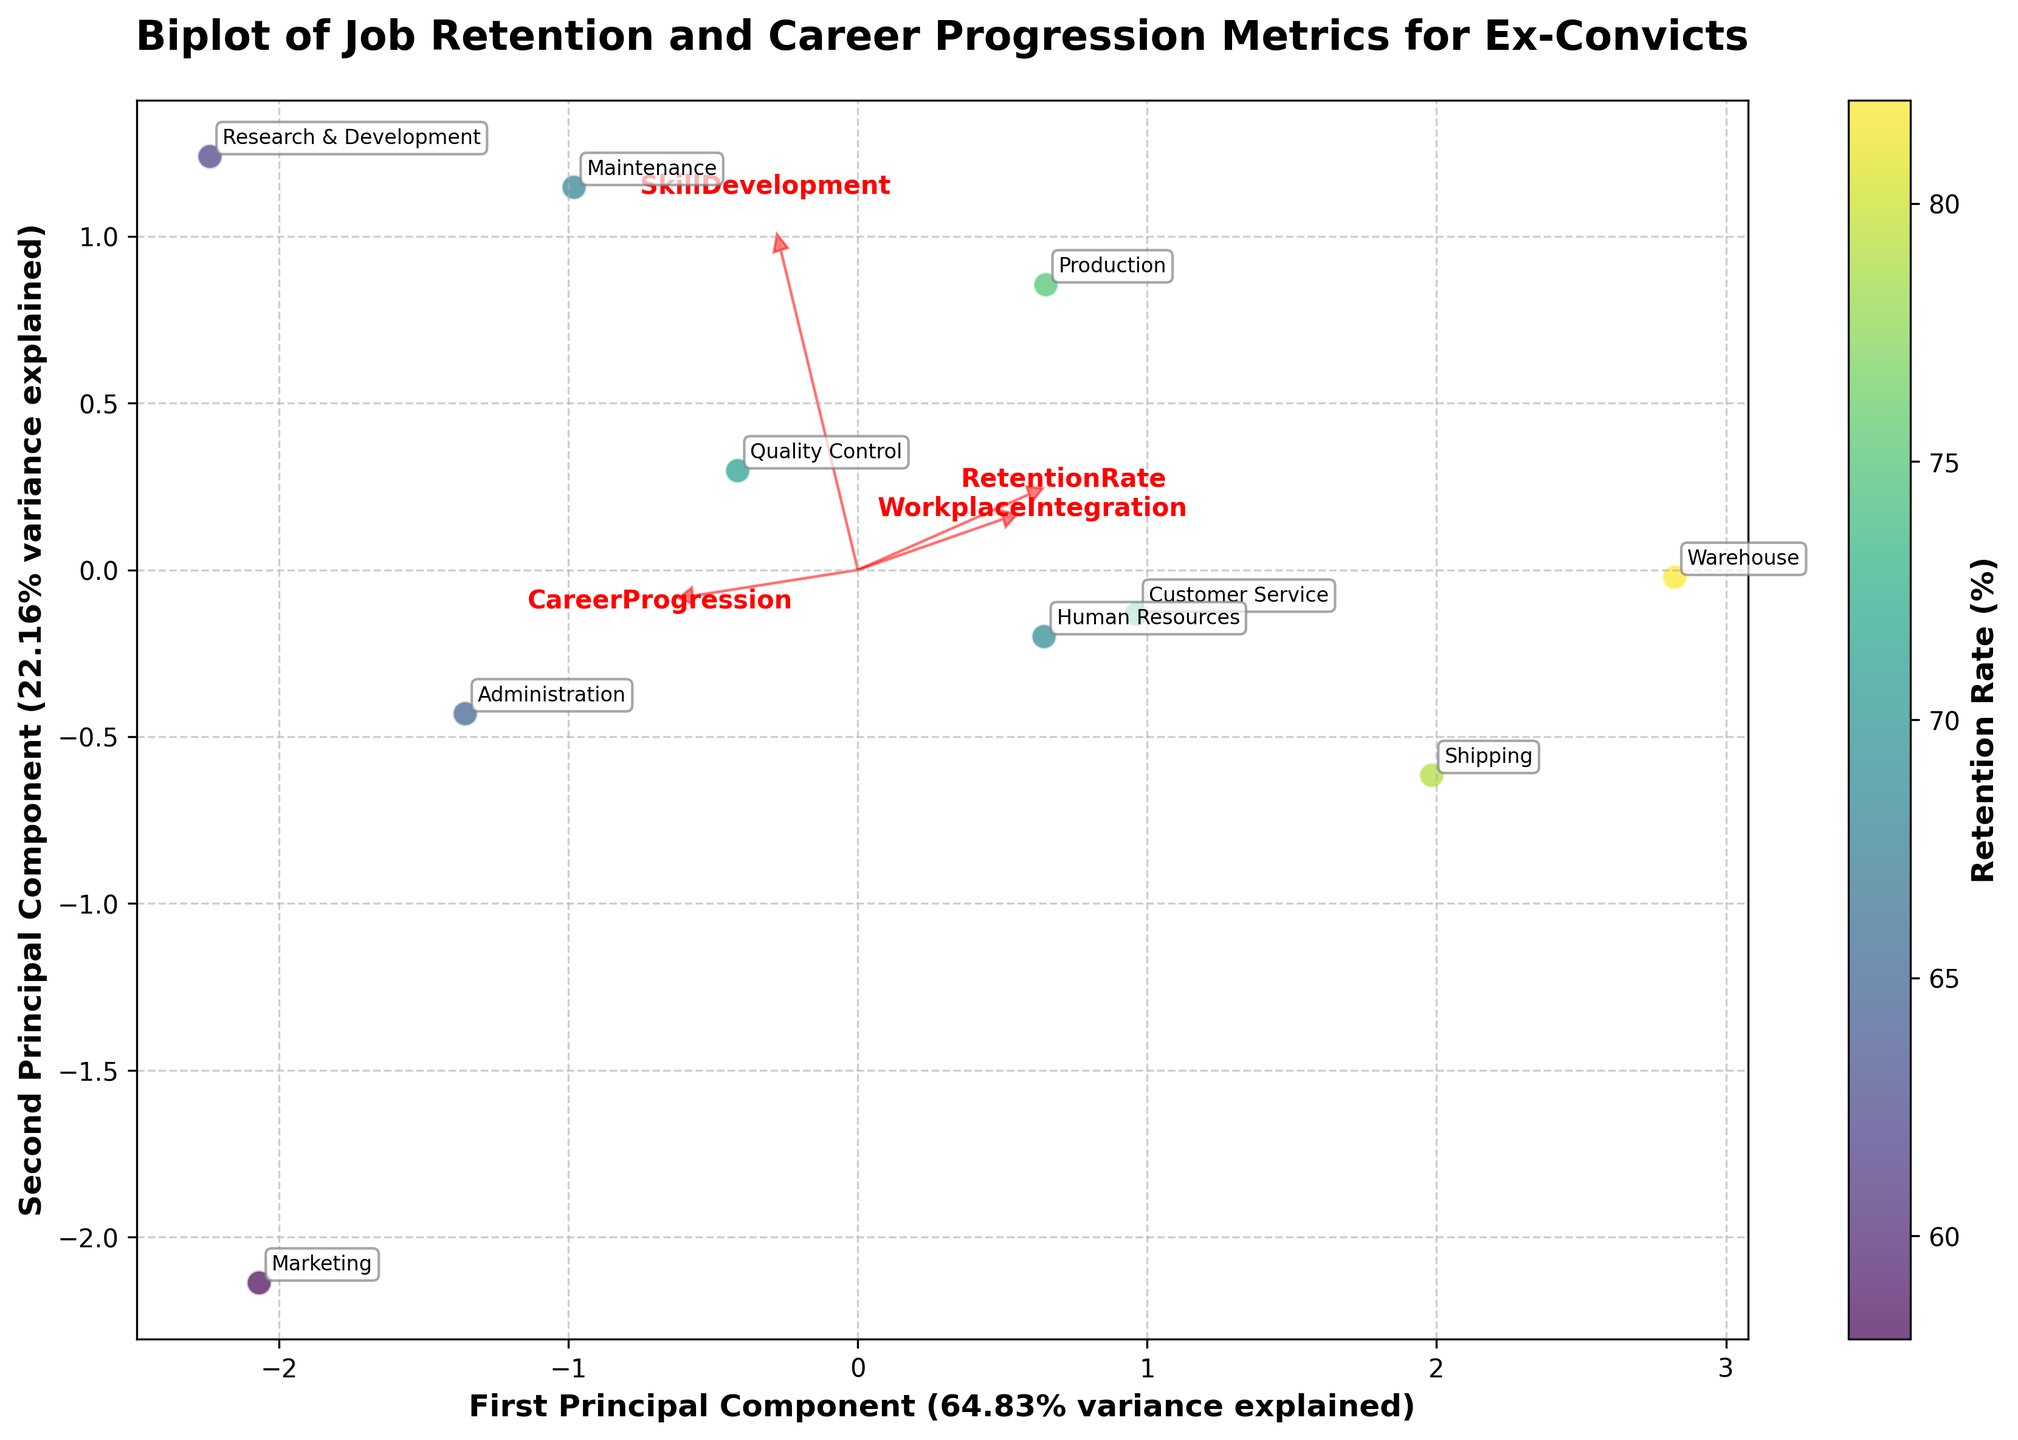What is the title of the plot? The title of the plot is typically located at the top center of the figure. It describes the theme of the visualization. In this case, the title is "Biplot of Job Retention and Career Progression Metrics for Ex-Convicts".
Answer: Biplot of Job Retention and Career Progression Metrics for Ex-Convicts What does the color of the data points represent? The color of the data points is indicated by the color bar on the right side of the plot. It represents the retention rate (%). The colormap (viridis in this case) shows a gradient from dark to light colors corresponding to lower to higher retention rates.
Answer: Retention Rate (%) Which department has the highest retention rate? By looking at the color gradient of the data points, we can see which one has the lightest color. The department with the lightest color point is 'Warehouse', which has the highest retention rate of 82%.
Answer: Warehouse Which department has the lowest retention rate? Similar to finding the highest retention rate, we look for the department with the darkest colored point. The department 'Marketing' has the darkest color point, indicating the lowest retention rate of 58%.
Answer: Marketing Which two dimensions are represented by the axes of the biplot and how much variance do they explain together? The x-axis and y-axis of the biplot represent the first and second principal components, respectively. The variance explained by each principal component is indicated in the labels of the axes. The first principal component explains 44.11% and the second 32.94%. Together, they explain 77.05% of the variance.
Answer: First (44.11%) and Second (32.94%) Principal Components; total 77.05% Which feature has the largest influence on the first principal component? The largest influence on the first principal component can be identified by the length of the feature vectors (arrows). "SkillDevelopment" has the longest arrow pointing in the direction of the first principal component.
Answer: SkillDevelopment Which department is closely associated with high levels of workplace integration? We can infer from the plot by observing the direction of the vector labeled "WorkplaceIntegration". The department closest to this vector will have high levels of workplace integration. 'Warehouse' is very close to this vector indicating high workplace integration.
Answer: Warehouse How is 'Research & Development' positioned on the second principal component relative to 'Marketing'? We compare their positions along the y-axis (second principal component). 'Research & Development' is positioned higher on the y-axis compared to 'Marketing', indicating that it scores higher on the second principal component.
Answer: Research & Development is higher What can you infer about 'Customer Service' in terms of its skill development and career progression? By observing the position of 'Customer Service' relative to the vectors "SkillDevelopment" and "CareerProgression", and projecting its data point onto these vectors, we can infer that it has moderate scores in both skill development and career progression as it lies near the middle of these vectors.
Answer: Moderate skill development and career progression Which department shows a contrasting trend to 'Production' in terms of career progression and skill development? By finding the department location that appears far opposite to 'Production' along the vectors "CareerProgression" and "SkillDevelopment". 'Research & Development' is the contrasting department to 'Production' since it is positioned far in the direction of higher career progression and skill development scores.
Answer: Research & Development 